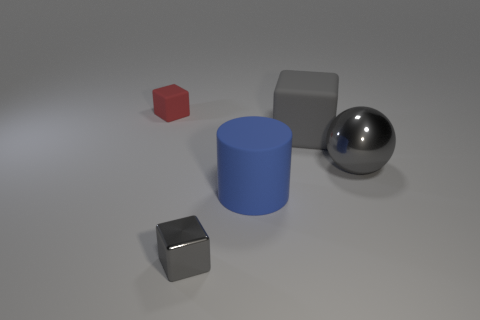Are the gray ball and the small object behind the small gray thing made of the same material?
Provide a succinct answer. No. There is a gray cube that is right of the small gray cube; what is it made of?
Keep it short and to the point. Rubber. Is the number of small things that are on the right side of the small gray metallic cube the same as the number of large gray spheres?
Your answer should be compact. No. Are there any other things that have the same size as the cylinder?
Make the answer very short. Yes. The gray thing to the left of the matte cube to the right of the small red cube is made of what material?
Your response must be concise. Metal. What shape is the thing that is left of the large cylinder and in front of the gray sphere?
Offer a terse response. Cube. The other red object that is the same shape as the small metal object is what size?
Provide a succinct answer. Small. Are there fewer metal cubes that are to the right of the big gray sphere than gray metal blocks?
Your response must be concise. Yes. What is the size of the block in front of the large shiny thing?
Offer a terse response. Small. What color is the other small rubber thing that is the same shape as the gray rubber object?
Keep it short and to the point. Red. 